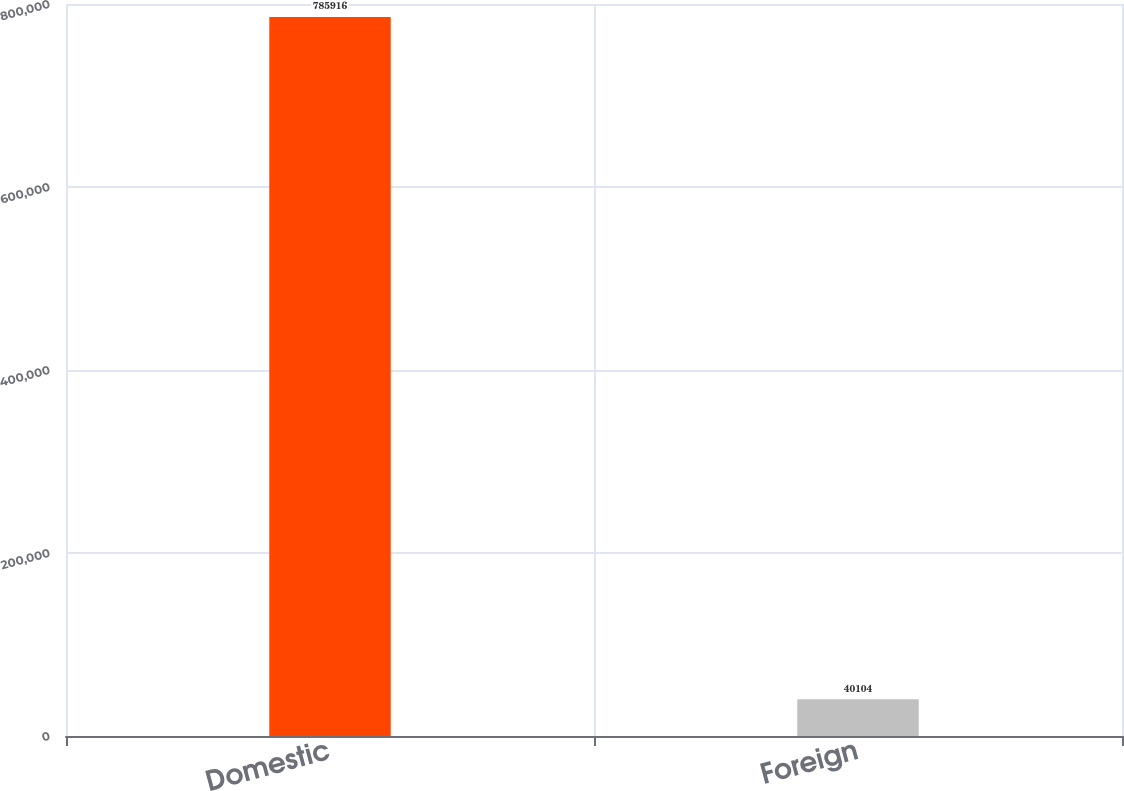<chart> <loc_0><loc_0><loc_500><loc_500><bar_chart><fcel>Domestic<fcel>Foreign<nl><fcel>785916<fcel>40104<nl></chart> 